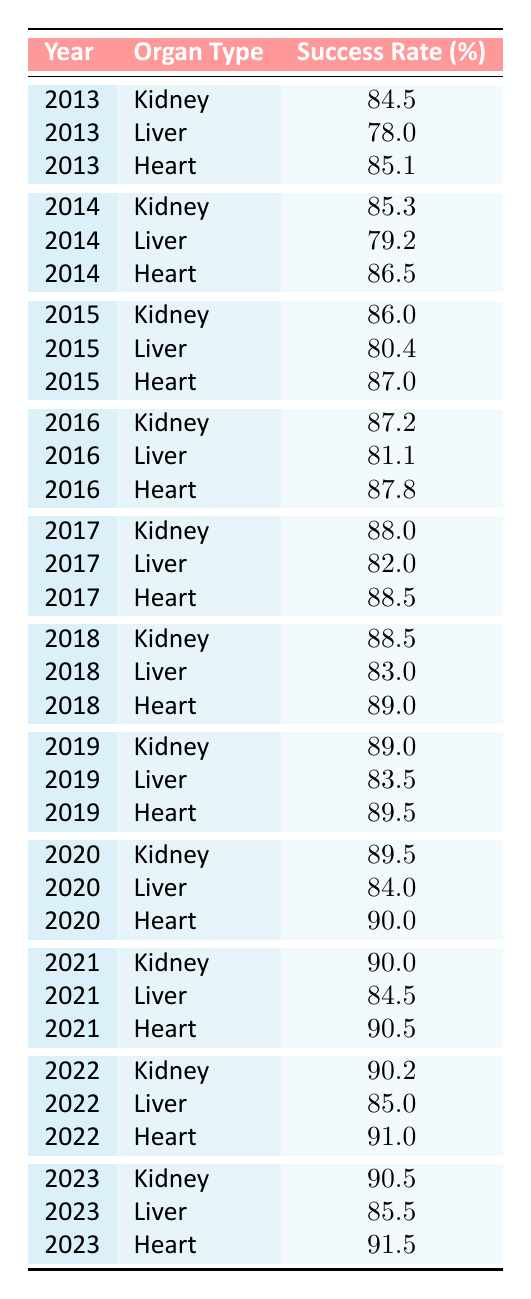What was the success rate for kidney transplants in 2019? The table shows that in 2019, the success rate for kidney transplants was reported as 89.0%. This value can be directly read from the corresponding row in the table.
Answer: 89.0 Which organ type had the highest success rate in 2021? In 2021, the success rates are 90.0% for kidney, 84.5% for liver, and 90.5% for heart. Comparing these values, 90.5% for heart is the highest.
Answer: Heart What was the average success rate for liver transplants from 2013 to 2023? The success rates for liver transplants over the years are 78.0, 79.2, 80.4, 81.1, 82.0, 83.0, 83.5, 84.0, 84.5, 85.0, and 85.5. Summing these gives 823.4, and dividing by 11 (the number of years) leads to an average of 74.9.
Answer: 74.9 Did the success rate for heart transplants consistently increase every year? Observing the heart transplant success rates: 85.1 (2013), 86.5 (2014), 87.0 (2015), 87.8 (2016), 88.5 (2017), 89.0 (2018), 89.5 (2019), 90.0 (2020), 90.5 (2021), 91.0 (2022), and 91.5 (2023) indicates a consistent increase. Thus, this statement is true.
Answer: Yes How much did the kidney transplant success rate increase from 2013 to 2023? The success rate for kidney transplants in 2013 was 84.5%. By 2023, it increased to 90.5%. The difference between these two values is 90.5 - 84.5 = 6.0. This shows an increase of 6.0%.
Answer: 6.0 